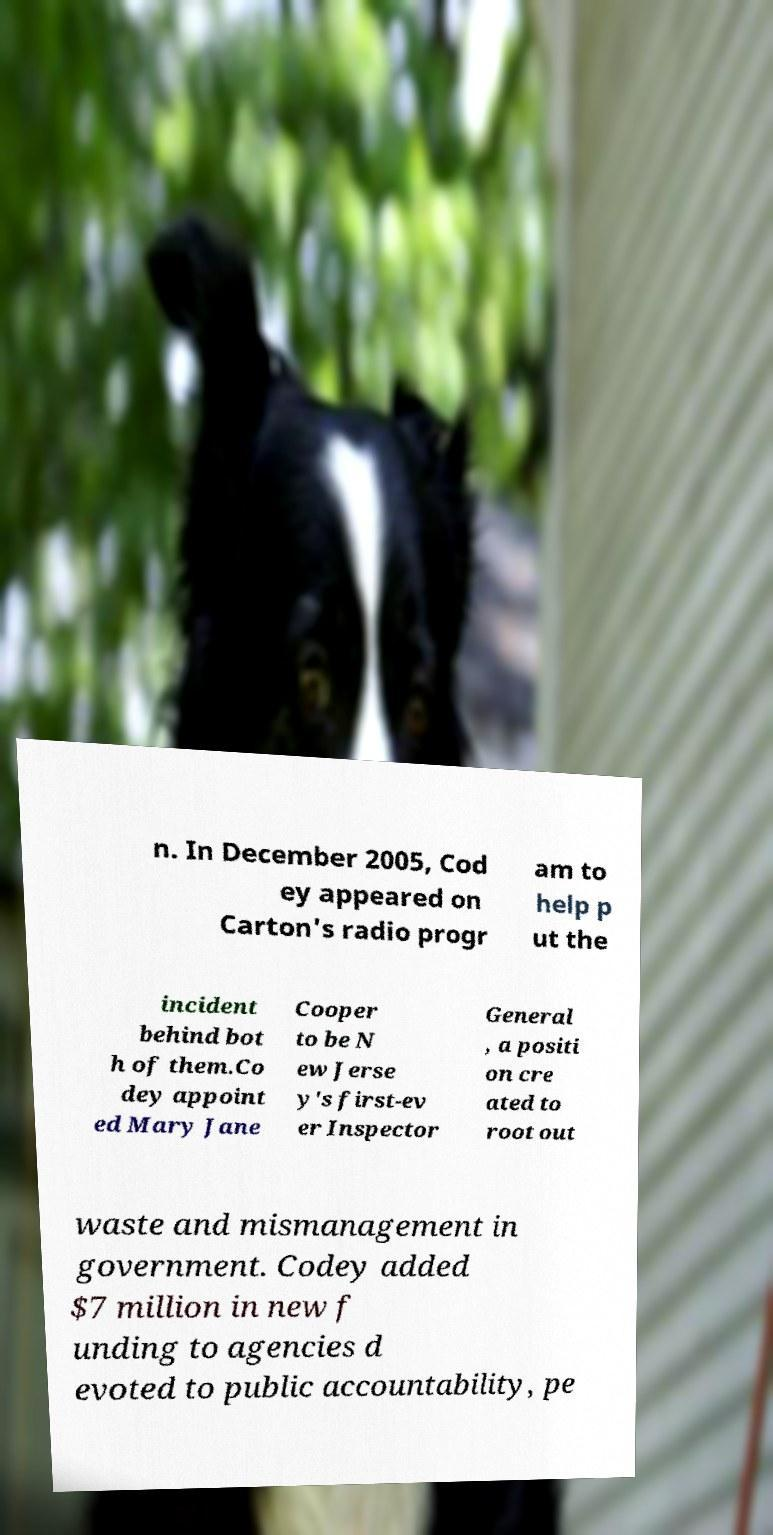For documentation purposes, I need the text within this image transcribed. Could you provide that? n. In December 2005, Cod ey appeared on Carton's radio progr am to help p ut the incident behind bot h of them.Co dey appoint ed Mary Jane Cooper to be N ew Jerse y's first-ev er Inspector General , a positi on cre ated to root out waste and mismanagement in government. Codey added $7 million in new f unding to agencies d evoted to public accountability, pe 